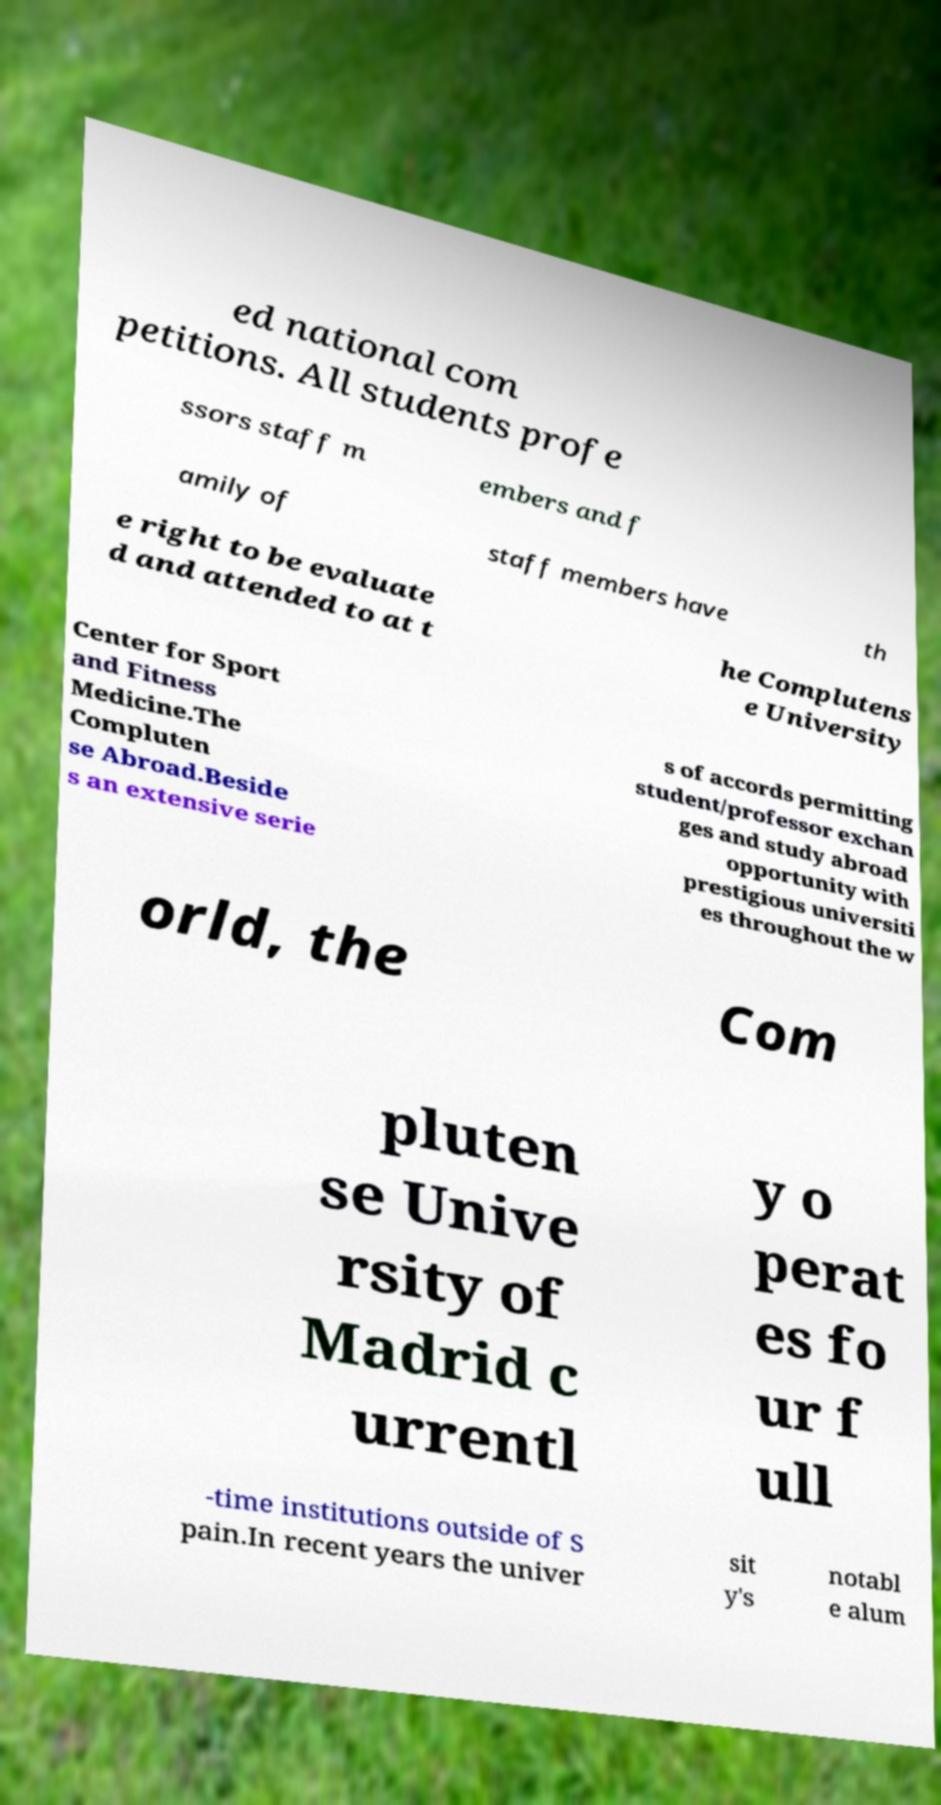There's text embedded in this image that I need extracted. Can you transcribe it verbatim? ed national com petitions. All students profe ssors staff m embers and f amily of staff members have th e right to be evaluate d and attended to at t he Complutens e University Center for Sport and Fitness Medicine.The Compluten se Abroad.Beside s an extensive serie s of accords permitting student/professor exchan ges and study abroad opportunity with prestigious universiti es throughout the w orld, the Com pluten se Unive rsity of Madrid c urrentl y o perat es fo ur f ull -time institutions outside of S pain.In recent years the univer sit y's notabl e alum 